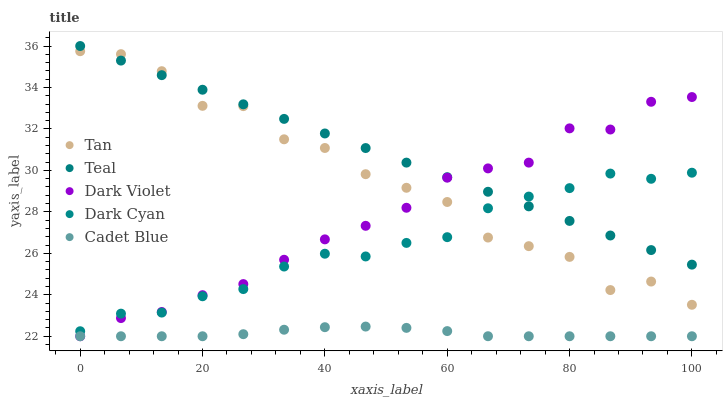Does Cadet Blue have the minimum area under the curve?
Answer yes or no. Yes. Does Teal have the maximum area under the curve?
Answer yes or no. Yes. Does Tan have the minimum area under the curve?
Answer yes or no. No. Does Tan have the maximum area under the curve?
Answer yes or no. No. Is Teal the smoothest?
Answer yes or no. Yes. Is Tan the roughest?
Answer yes or no. Yes. Is Cadet Blue the smoothest?
Answer yes or no. No. Is Cadet Blue the roughest?
Answer yes or no. No. Does Cadet Blue have the lowest value?
Answer yes or no. Yes. Does Tan have the lowest value?
Answer yes or no. No. Does Teal have the highest value?
Answer yes or no. Yes. Does Tan have the highest value?
Answer yes or no. No. Is Cadet Blue less than Teal?
Answer yes or no. Yes. Is Teal greater than Cadet Blue?
Answer yes or no. Yes. Does Dark Cyan intersect Dark Violet?
Answer yes or no. Yes. Is Dark Cyan less than Dark Violet?
Answer yes or no. No. Is Dark Cyan greater than Dark Violet?
Answer yes or no. No. Does Cadet Blue intersect Teal?
Answer yes or no. No. 